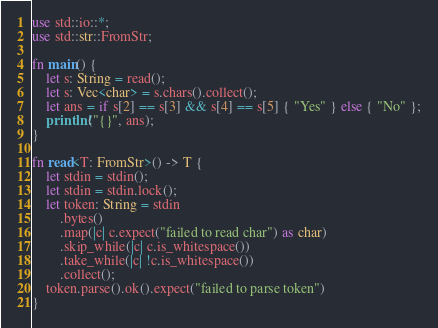<code> <loc_0><loc_0><loc_500><loc_500><_Rust_>use std::io::*;
use std::str::FromStr;

fn main() {
	let s: String = read();
	let s: Vec<char> = s.chars().collect();
	let ans = if s[2] == s[3] && s[4] == s[5] { "Yes" } else { "No" };
	println!("{}", ans);
}

fn read<T: FromStr>() -> T {
	let stdin = stdin();
	let stdin = stdin.lock();
	let token: String = stdin
		.bytes()
		.map(|c| c.expect("failed to read char") as char)
		.skip_while(|c| c.is_whitespace())
		.take_while(|c| !c.is_whitespace())
		.collect();
	token.parse().ok().expect("failed to parse token")
}

</code> 